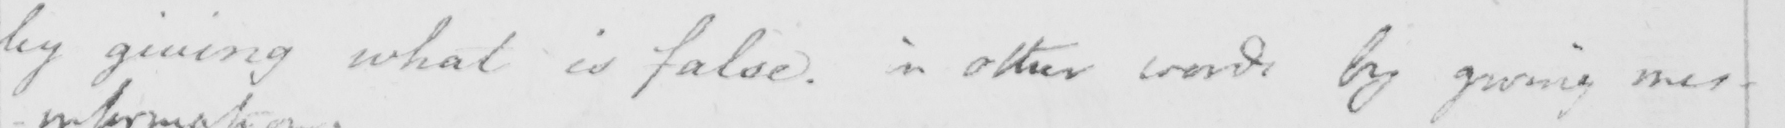Can you tell me what this handwritten text says? by giving what is false . in other words by giving mis- 